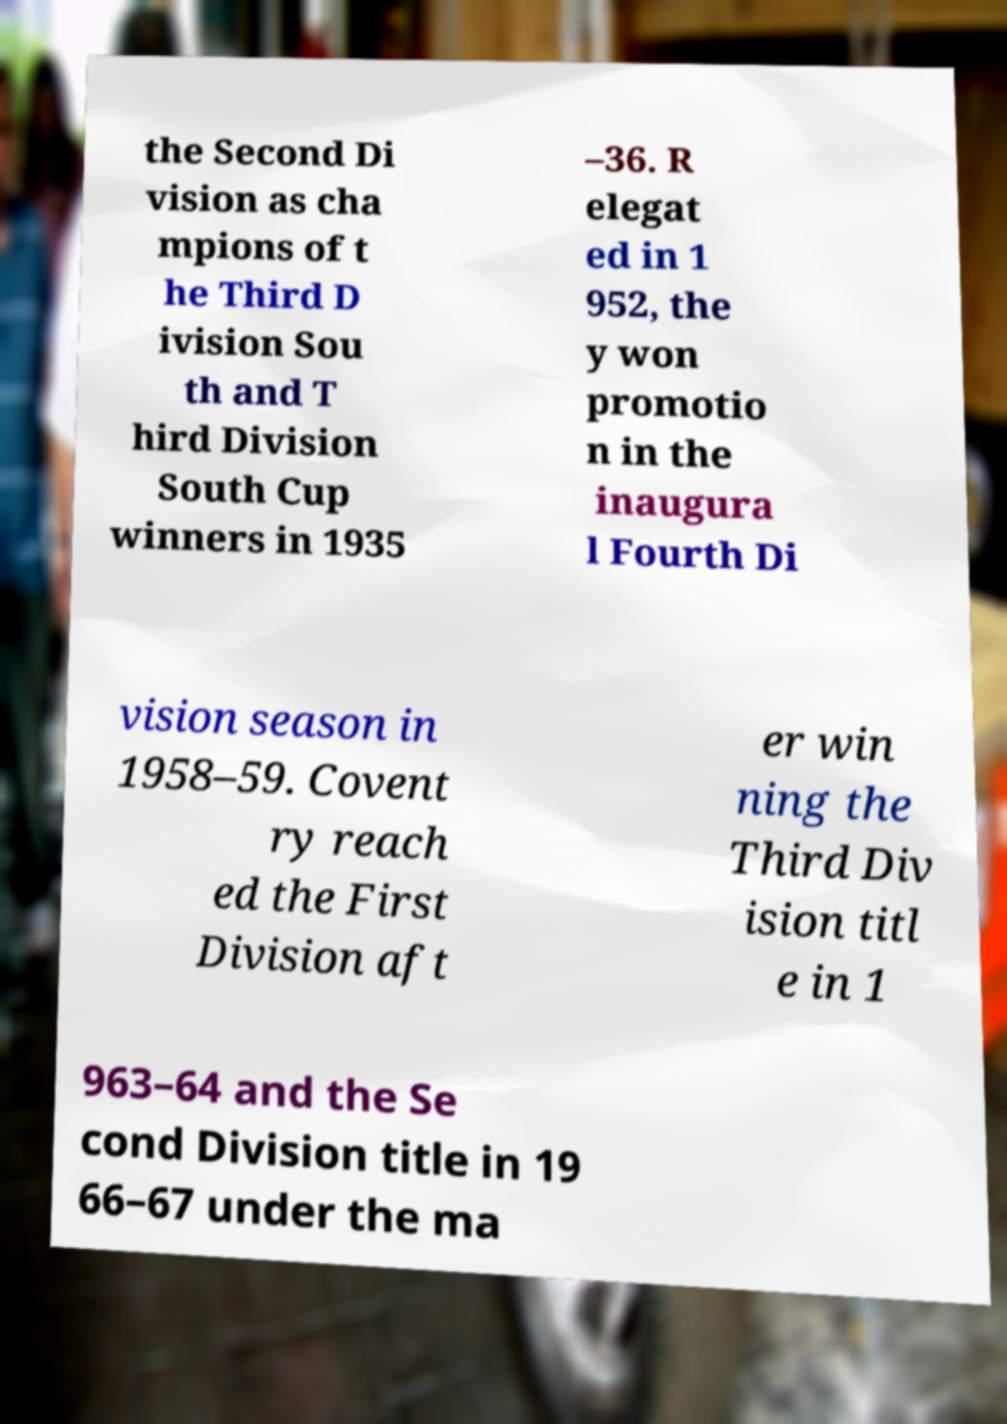Can you accurately transcribe the text from the provided image for me? the Second Di vision as cha mpions of t he Third D ivision Sou th and T hird Division South Cup winners in 1935 –36. R elegat ed in 1 952, the y won promotio n in the inaugura l Fourth Di vision season in 1958–59. Covent ry reach ed the First Division aft er win ning the Third Div ision titl e in 1 963–64 and the Se cond Division title in 19 66–67 under the ma 